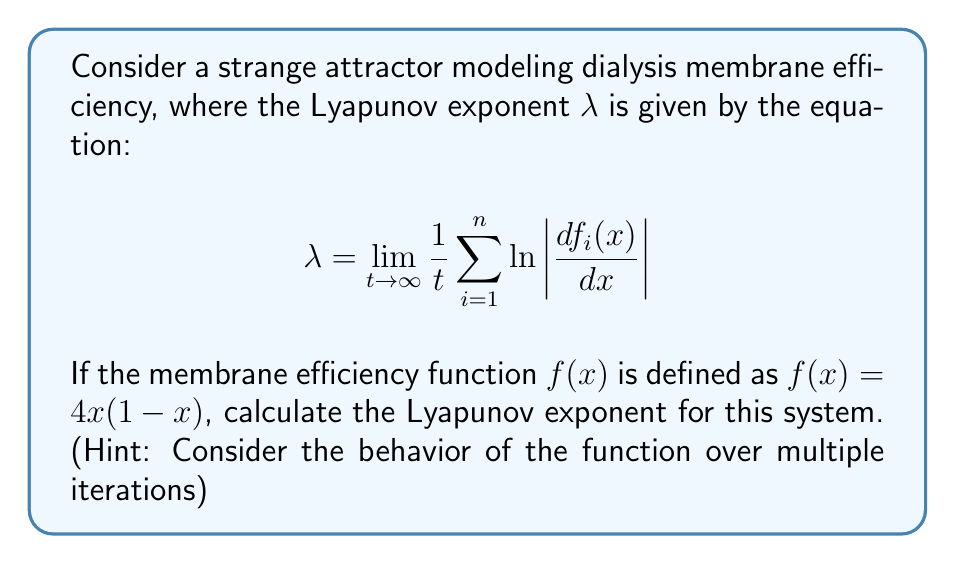Solve this math problem. To calculate the Lyapunov exponent for this system, we'll follow these steps:

1) First, we need to find $\frac{df(x)}{dx}$:
   $$\frac{df(x)}{dx} = 4(1-x) - 4x = 4 - 8x$$

2) Now, we need to calculate $\ln \left|\frac{df(x)}{dx}\right|$ for multiple iterations:

   For the first iteration (i=1), x = 0.5 (assuming we start at the midpoint):
   $$\ln \left|\frac{df(0.5)}{dx}\right| = \ln |4 - 8(0.5)| = \ln |0| \text{ (undefined)}$$

   For the second iteration (i=2), x = f(0.5) = 1:
   $$\ln \left|\frac{df(1)}{dx}\right| = \ln |4 - 8(1)| = \ln |-4| = \ln 4 \approx 1.3863$$

   For the third iteration (i=3), x = f(1) = 0:
   $$\ln \left|\frac{df(0)}{dx}\right| = \ln |4 - 8(0)| = \ln 4 \approx 1.3863$$

3) We can see that the system oscillates between x = 0 and x = 1 after the first iteration.

4) The Lyapunov exponent is the average of these values as t approaches infinity:

   $$λ = \lim_{t \to \infty} \frac{1}{t} (1.3863 + 1.3863 + 1.3863 + ...)$$

5) As t approaches infinity, this converges to:

   $$λ = 1.3863$$

This positive Lyapunov exponent indicates chaotic behavior in the system, which is characteristic of strange attractors.
Answer: $λ = \ln 4 \approx 1.3863$ 